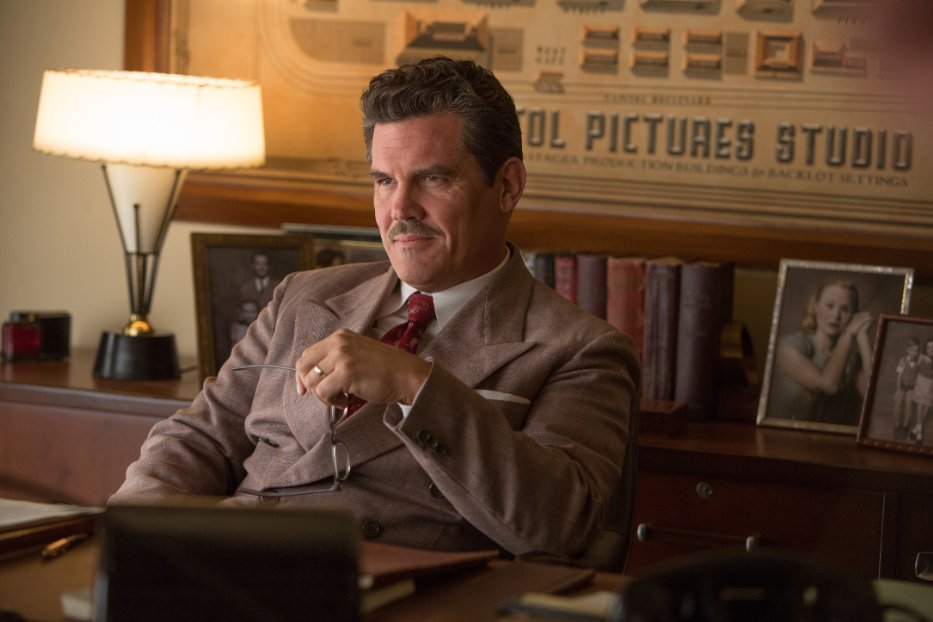Create a whimsical and imaginative question about this scene. What if the lamp on Eddie Mannix's desk could talk? What secrets about Hollywood's golden age might it reveal, having silently witnessed countless high-stakes meetings and legendary tales? 